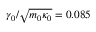<formula> <loc_0><loc_0><loc_500><loc_500>\gamma _ { 0 } / \sqrt { m _ { 0 } \kappa _ { 0 } } = 0 . 0 8 5</formula> 